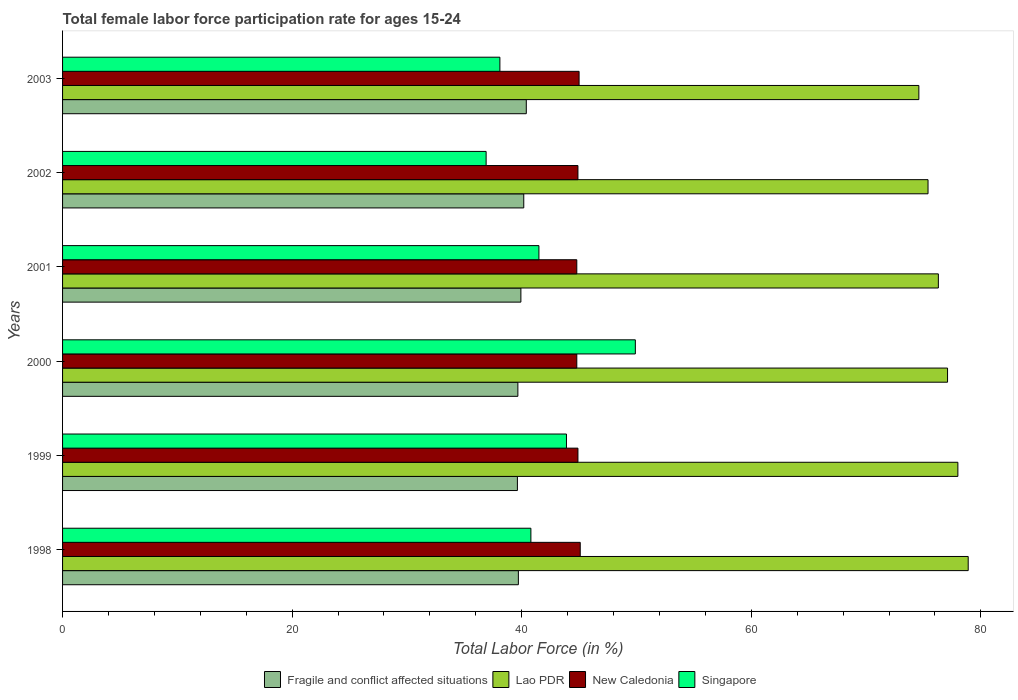How many different coloured bars are there?
Your answer should be very brief. 4. How many groups of bars are there?
Your response must be concise. 6. Are the number of bars per tick equal to the number of legend labels?
Provide a short and direct response. Yes. Are the number of bars on each tick of the Y-axis equal?
Provide a short and direct response. Yes. How many bars are there on the 2nd tick from the top?
Keep it short and to the point. 4. How many bars are there on the 6th tick from the bottom?
Offer a very short reply. 4. What is the female labor force participation rate in Singapore in 1999?
Give a very brief answer. 43.9. Across all years, what is the maximum female labor force participation rate in New Caledonia?
Your response must be concise. 45.1. Across all years, what is the minimum female labor force participation rate in Singapore?
Provide a succinct answer. 36.9. In which year was the female labor force participation rate in New Caledonia maximum?
Make the answer very short. 1998. What is the total female labor force participation rate in Singapore in the graph?
Ensure brevity in your answer.  251.1. What is the difference between the female labor force participation rate in Fragile and conflict affected situations in 1998 and that in 2000?
Make the answer very short. 0.04. What is the difference between the female labor force participation rate in Fragile and conflict affected situations in 2000 and the female labor force participation rate in Lao PDR in 2001?
Provide a short and direct response. -36.63. What is the average female labor force participation rate in Lao PDR per year?
Give a very brief answer. 76.72. In the year 2000, what is the difference between the female labor force participation rate in Singapore and female labor force participation rate in Lao PDR?
Your answer should be compact. -27.2. In how many years, is the female labor force participation rate in Fragile and conflict affected situations greater than 8 %?
Offer a terse response. 6. What is the ratio of the female labor force participation rate in Fragile and conflict affected situations in 1998 to that in 2002?
Keep it short and to the point. 0.99. Is the difference between the female labor force participation rate in Singapore in 1998 and 2001 greater than the difference between the female labor force participation rate in Lao PDR in 1998 and 2001?
Provide a succinct answer. No. What is the difference between the highest and the second highest female labor force participation rate in Fragile and conflict affected situations?
Keep it short and to the point. 0.22. What is the difference between the highest and the lowest female labor force participation rate in New Caledonia?
Provide a short and direct response. 0.3. Is the sum of the female labor force participation rate in Singapore in 2000 and 2001 greater than the maximum female labor force participation rate in Lao PDR across all years?
Your answer should be compact. Yes. What does the 1st bar from the top in 2000 represents?
Provide a short and direct response. Singapore. What does the 2nd bar from the bottom in 1999 represents?
Provide a succinct answer. Lao PDR. How many bars are there?
Give a very brief answer. 24. Are the values on the major ticks of X-axis written in scientific E-notation?
Offer a terse response. No. Does the graph contain grids?
Your answer should be very brief. No. How are the legend labels stacked?
Offer a terse response. Horizontal. What is the title of the graph?
Make the answer very short. Total female labor force participation rate for ages 15-24. What is the label or title of the X-axis?
Provide a short and direct response. Total Labor Force (in %). What is the label or title of the Y-axis?
Offer a very short reply. Years. What is the Total Labor Force (in %) of Fragile and conflict affected situations in 1998?
Your answer should be very brief. 39.71. What is the Total Labor Force (in %) in Lao PDR in 1998?
Offer a terse response. 78.9. What is the Total Labor Force (in %) in New Caledonia in 1998?
Your response must be concise. 45.1. What is the Total Labor Force (in %) of Singapore in 1998?
Offer a very short reply. 40.8. What is the Total Labor Force (in %) of Fragile and conflict affected situations in 1999?
Offer a terse response. 39.63. What is the Total Labor Force (in %) in New Caledonia in 1999?
Your answer should be very brief. 44.9. What is the Total Labor Force (in %) in Singapore in 1999?
Provide a succinct answer. 43.9. What is the Total Labor Force (in %) of Fragile and conflict affected situations in 2000?
Keep it short and to the point. 39.67. What is the Total Labor Force (in %) in Lao PDR in 2000?
Provide a succinct answer. 77.1. What is the Total Labor Force (in %) in New Caledonia in 2000?
Your response must be concise. 44.8. What is the Total Labor Force (in %) of Singapore in 2000?
Give a very brief answer. 49.9. What is the Total Labor Force (in %) of Fragile and conflict affected situations in 2001?
Provide a short and direct response. 39.93. What is the Total Labor Force (in %) in Lao PDR in 2001?
Your answer should be very brief. 76.3. What is the Total Labor Force (in %) in New Caledonia in 2001?
Ensure brevity in your answer.  44.8. What is the Total Labor Force (in %) in Singapore in 2001?
Your response must be concise. 41.5. What is the Total Labor Force (in %) in Fragile and conflict affected situations in 2002?
Your answer should be very brief. 40.18. What is the Total Labor Force (in %) in Lao PDR in 2002?
Offer a very short reply. 75.4. What is the Total Labor Force (in %) of New Caledonia in 2002?
Ensure brevity in your answer.  44.9. What is the Total Labor Force (in %) in Singapore in 2002?
Offer a very short reply. 36.9. What is the Total Labor Force (in %) of Fragile and conflict affected situations in 2003?
Make the answer very short. 40.4. What is the Total Labor Force (in %) of Lao PDR in 2003?
Provide a succinct answer. 74.6. What is the Total Labor Force (in %) in Singapore in 2003?
Your answer should be compact. 38.1. Across all years, what is the maximum Total Labor Force (in %) in Fragile and conflict affected situations?
Offer a terse response. 40.4. Across all years, what is the maximum Total Labor Force (in %) in Lao PDR?
Make the answer very short. 78.9. Across all years, what is the maximum Total Labor Force (in %) in New Caledonia?
Provide a short and direct response. 45.1. Across all years, what is the maximum Total Labor Force (in %) in Singapore?
Your response must be concise. 49.9. Across all years, what is the minimum Total Labor Force (in %) of Fragile and conflict affected situations?
Provide a short and direct response. 39.63. Across all years, what is the minimum Total Labor Force (in %) in Lao PDR?
Keep it short and to the point. 74.6. Across all years, what is the minimum Total Labor Force (in %) of New Caledonia?
Give a very brief answer. 44.8. Across all years, what is the minimum Total Labor Force (in %) in Singapore?
Make the answer very short. 36.9. What is the total Total Labor Force (in %) in Fragile and conflict affected situations in the graph?
Your response must be concise. 239.51. What is the total Total Labor Force (in %) of Lao PDR in the graph?
Provide a succinct answer. 460.3. What is the total Total Labor Force (in %) of New Caledonia in the graph?
Ensure brevity in your answer.  269.5. What is the total Total Labor Force (in %) of Singapore in the graph?
Your answer should be very brief. 251.1. What is the difference between the Total Labor Force (in %) of Fragile and conflict affected situations in 1998 and that in 1999?
Make the answer very short. 0.08. What is the difference between the Total Labor Force (in %) in Lao PDR in 1998 and that in 1999?
Your answer should be very brief. 0.9. What is the difference between the Total Labor Force (in %) in Singapore in 1998 and that in 1999?
Provide a succinct answer. -3.1. What is the difference between the Total Labor Force (in %) in Fragile and conflict affected situations in 1998 and that in 2000?
Ensure brevity in your answer.  0.04. What is the difference between the Total Labor Force (in %) of Lao PDR in 1998 and that in 2000?
Offer a very short reply. 1.8. What is the difference between the Total Labor Force (in %) of Singapore in 1998 and that in 2000?
Provide a succinct answer. -9.1. What is the difference between the Total Labor Force (in %) in Fragile and conflict affected situations in 1998 and that in 2001?
Make the answer very short. -0.22. What is the difference between the Total Labor Force (in %) of New Caledonia in 1998 and that in 2001?
Your response must be concise. 0.3. What is the difference between the Total Labor Force (in %) of Singapore in 1998 and that in 2001?
Offer a very short reply. -0.7. What is the difference between the Total Labor Force (in %) in Fragile and conflict affected situations in 1998 and that in 2002?
Your response must be concise. -0.47. What is the difference between the Total Labor Force (in %) of Lao PDR in 1998 and that in 2002?
Your answer should be very brief. 3.5. What is the difference between the Total Labor Force (in %) in New Caledonia in 1998 and that in 2002?
Provide a succinct answer. 0.2. What is the difference between the Total Labor Force (in %) of Fragile and conflict affected situations in 1998 and that in 2003?
Give a very brief answer. -0.69. What is the difference between the Total Labor Force (in %) of New Caledonia in 1998 and that in 2003?
Offer a terse response. 0.1. What is the difference between the Total Labor Force (in %) of Fragile and conflict affected situations in 1999 and that in 2000?
Offer a terse response. -0.04. What is the difference between the Total Labor Force (in %) of Singapore in 1999 and that in 2000?
Ensure brevity in your answer.  -6. What is the difference between the Total Labor Force (in %) in Fragile and conflict affected situations in 1999 and that in 2001?
Provide a succinct answer. -0.3. What is the difference between the Total Labor Force (in %) in New Caledonia in 1999 and that in 2001?
Provide a succinct answer. 0.1. What is the difference between the Total Labor Force (in %) of Fragile and conflict affected situations in 1999 and that in 2002?
Give a very brief answer. -0.55. What is the difference between the Total Labor Force (in %) of Lao PDR in 1999 and that in 2002?
Your answer should be compact. 2.6. What is the difference between the Total Labor Force (in %) of New Caledonia in 1999 and that in 2002?
Ensure brevity in your answer.  0. What is the difference between the Total Labor Force (in %) in Fragile and conflict affected situations in 1999 and that in 2003?
Your response must be concise. -0.78. What is the difference between the Total Labor Force (in %) of Fragile and conflict affected situations in 2000 and that in 2001?
Provide a short and direct response. -0.26. What is the difference between the Total Labor Force (in %) of Fragile and conflict affected situations in 2000 and that in 2002?
Your response must be concise. -0.51. What is the difference between the Total Labor Force (in %) in Lao PDR in 2000 and that in 2002?
Your answer should be compact. 1.7. What is the difference between the Total Labor Force (in %) in Singapore in 2000 and that in 2002?
Your answer should be very brief. 13. What is the difference between the Total Labor Force (in %) of Fragile and conflict affected situations in 2000 and that in 2003?
Offer a terse response. -0.73. What is the difference between the Total Labor Force (in %) in Lao PDR in 2000 and that in 2003?
Offer a terse response. 2.5. What is the difference between the Total Labor Force (in %) in New Caledonia in 2000 and that in 2003?
Ensure brevity in your answer.  -0.2. What is the difference between the Total Labor Force (in %) in Fragile and conflict affected situations in 2001 and that in 2002?
Your answer should be compact. -0.25. What is the difference between the Total Labor Force (in %) of New Caledonia in 2001 and that in 2002?
Keep it short and to the point. -0.1. What is the difference between the Total Labor Force (in %) of Fragile and conflict affected situations in 2001 and that in 2003?
Offer a very short reply. -0.47. What is the difference between the Total Labor Force (in %) of Singapore in 2001 and that in 2003?
Provide a short and direct response. 3.4. What is the difference between the Total Labor Force (in %) in Fragile and conflict affected situations in 2002 and that in 2003?
Provide a succinct answer. -0.22. What is the difference between the Total Labor Force (in %) in Singapore in 2002 and that in 2003?
Your answer should be compact. -1.2. What is the difference between the Total Labor Force (in %) of Fragile and conflict affected situations in 1998 and the Total Labor Force (in %) of Lao PDR in 1999?
Your response must be concise. -38.29. What is the difference between the Total Labor Force (in %) of Fragile and conflict affected situations in 1998 and the Total Labor Force (in %) of New Caledonia in 1999?
Provide a succinct answer. -5.19. What is the difference between the Total Labor Force (in %) in Fragile and conflict affected situations in 1998 and the Total Labor Force (in %) in Singapore in 1999?
Offer a terse response. -4.19. What is the difference between the Total Labor Force (in %) in New Caledonia in 1998 and the Total Labor Force (in %) in Singapore in 1999?
Ensure brevity in your answer.  1.2. What is the difference between the Total Labor Force (in %) in Fragile and conflict affected situations in 1998 and the Total Labor Force (in %) in Lao PDR in 2000?
Provide a succinct answer. -37.39. What is the difference between the Total Labor Force (in %) of Fragile and conflict affected situations in 1998 and the Total Labor Force (in %) of New Caledonia in 2000?
Provide a short and direct response. -5.09. What is the difference between the Total Labor Force (in %) of Fragile and conflict affected situations in 1998 and the Total Labor Force (in %) of Singapore in 2000?
Provide a short and direct response. -10.19. What is the difference between the Total Labor Force (in %) in Lao PDR in 1998 and the Total Labor Force (in %) in New Caledonia in 2000?
Keep it short and to the point. 34.1. What is the difference between the Total Labor Force (in %) in Lao PDR in 1998 and the Total Labor Force (in %) in Singapore in 2000?
Your response must be concise. 29. What is the difference between the Total Labor Force (in %) of Fragile and conflict affected situations in 1998 and the Total Labor Force (in %) of Lao PDR in 2001?
Keep it short and to the point. -36.59. What is the difference between the Total Labor Force (in %) of Fragile and conflict affected situations in 1998 and the Total Labor Force (in %) of New Caledonia in 2001?
Provide a short and direct response. -5.09. What is the difference between the Total Labor Force (in %) of Fragile and conflict affected situations in 1998 and the Total Labor Force (in %) of Singapore in 2001?
Provide a short and direct response. -1.79. What is the difference between the Total Labor Force (in %) in Lao PDR in 1998 and the Total Labor Force (in %) in New Caledonia in 2001?
Your answer should be very brief. 34.1. What is the difference between the Total Labor Force (in %) of Lao PDR in 1998 and the Total Labor Force (in %) of Singapore in 2001?
Your response must be concise. 37.4. What is the difference between the Total Labor Force (in %) in Fragile and conflict affected situations in 1998 and the Total Labor Force (in %) in Lao PDR in 2002?
Your answer should be compact. -35.69. What is the difference between the Total Labor Force (in %) of Fragile and conflict affected situations in 1998 and the Total Labor Force (in %) of New Caledonia in 2002?
Your answer should be very brief. -5.19. What is the difference between the Total Labor Force (in %) of Fragile and conflict affected situations in 1998 and the Total Labor Force (in %) of Singapore in 2002?
Your answer should be very brief. 2.81. What is the difference between the Total Labor Force (in %) of Fragile and conflict affected situations in 1998 and the Total Labor Force (in %) of Lao PDR in 2003?
Offer a terse response. -34.89. What is the difference between the Total Labor Force (in %) of Fragile and conflict affected situations in 1998 and the Total Labor Force (in %) of New Caledonia in 2003?
Your answer should be very brief. -5.29. What is the difference between the Total Labor Force (in %) in Fragile and conflict affected situations in 1998 and the Total Labor Force (in %) in Singapore in 2003?
Make the answer very short. 1.61. What is the difference between the Total Labor Force (in %) of Lao PDR in 1998 and the Total Labor Force (in %) of New Caledonia in 2003?
Make the answer very short. 33.9. What is the difference between the Total Labor Force (in %) of Lao PDR in 1998 and the Total Labor Force (in %) of Singapore in 2003?
Keep it short and to the point. 40.8. What is the difference between the Total Labor Force (in %) of New Caledonia in 1998 and the Total Labor Force (in %) of Singapore in 2003?
Provide a short and direct response. 7. What is the difference between the Total Labor Force (in %) in Fragile and conflict affected situations in 1999 and the Total Labor Force (in %) in Lao PDR in 2000?
Give a very brief answer. -37.47. What is the difference between the Total Labor Force (in %) of Fragile and conflict affected situations in 1999 and the Total Labor Force (in %) of New Caledonia in 2000?
Ensure brevity in your answer.  -5.17. What is the difference between the Total Labor Force (in %) in Fragile and conflict affected situations in 1999 and the Total Labor Force (in %) in Singapore in 2000?
Your answer should be very brief. -10.27. What is the difference between the Total Labor Force (in %) of Lao PDR in 1999 and the Total Labor Force (in %) of New Caledonia in 2000?
Your answer should be compact. 33.2. What is the difference between the Total Labor Force (in %) of Lao PDR in 1999 and the Total Labor Force (in %) of Singapore in 2000?
Your answer should be compact. 28.1. What is the difference between the Total Labor Force (in %) of Fragile and conflict affected situations in 1999 and the Total Labor Force (in %) of Lao PDR in 2001?
Provide a short and direct response. -36.67. What is the difference between the Total Labor Force (in %) of Fragile and conflict affected situations in 1999 and the Total Labor Force (in %) of New Caledonia in 2001?
Offer a very short reply. -5.17. What is the difference between the Total Labor Force (in %) in Fragile and conflict affected situations in 1999 and the Total Labor Force (in %) in Singapore in 2001?
Offer a very short reply. -1.87. What is the difference between the Total Labor Force (in %) in Lao PDR in 1999 and the Total Labor Force (in %) in New Caledonia in 2001?
Keep it short and to the point. 33.2. What is the difference between the Total Labor Force (in %) of Lao PDR in 1999 and the Total Labor Force (in %) of Singapore in 2001?
Offer a terse response. 36.5. What is the difference between the Total Labor Force (in %) in Fragile and conflict affected situations in 1999 and the Total Labor Force (in %) in Lao PDR in 2002?
Offer a very short reply. -35.77. What is the difference between the Total Labor Force (in %) in Fragile and conflict affected situations in 1999 and the Total Labor Force (in %) in New Caledonia in 2002?
Your answer should be very brief. -5.27. What is the difference between the Total Labor Force (in %) of Fragile and conflict affected situations in 1999 and the Total Labor Force (in %) of Singapore in 2002?
Give a very brief answer. 2.73. What is the difference between the Total Labor Force (in %) in Lao PDR in 1999 and the Total Labor Force (in %) in New Caledonia in 2002?
Give a very brief answer. 33.1. What is the difference between the Total Labor Force (in %) of Lao PDR in 1999 and the Total Labor Force (in %) of Singapore in 2002?
Keep it short and to the point. 41.1. What is the difference between the Total Labor Force (in %) of Fragile and conflict affected situations in 1999 and the Total Labor Force (in %) of Lao PDR in 2003?
Your answer should be compact. -34.97. What is the difference between the Total Labor Force (in %) of Fragile and conflict affected situations in 1999 and the Total Labor Force (in %) of New Caledonia in 2003?
Give a very brief answer. -5.37. What is the difference between the Total Labor Force (in %) in Fragile and conflict affected situations in 1999 and the Total Labor Force (in %) in Singapore in 2003?
Keep it short and to the point. 1.53. What is the difference between the Total Labor Force (in %) in Lao PDR in 1999 and the Total Labor Force (in %) in Singapore in 2003?
Keep it short and to the point. 39.9. What is the difference between the Total Labor Force (in %) in New Caledonia in 1999 and the Total Labor Force (in %) in Singapore in 2003?
Make the answer very short. 6.8. What is the difference between the Total Labor Force (in %) in Fragile and conflict affected situations in 2000 and the Total Labor Force (in %) in Lao PDR in 2001?
Give a very brief answer. -36.63. What is the difference between the Total Labor Force (in %) of Fragile and conflict affected situations in 2000 and the Total Labor Force (in %) of New Caledonia in 2001?
Provide a short and direct response. -5.13. What is the difference between the Total Labor Force (in %) in Fragile and conflict affected situations in 2000 and the Total Labor Force (in %) in Singapore in 2001?
Offer a very short reply. -1.83. What is the difference between the Total Labor Force (in %) of Lao PDR in 2000 and the Total Labor Force (in %) of New Caledonia in 2001?
Provide a short and direct response. 32.3. What is the difference between the Total Labor Force (in %) of Lao PDR in 2000 and the Total Labor Force (in %) of Singapore in 2001?
Keep it short and to the point. 35.6. What is the difference between the Total Labor Force (in %) of New Caledonia in 2000 and the Total Labor Force (in %) of Singapore in 2001?
Your answer should be compact. 3.3. What is the difference between the Total Labor Force (in %) of Fragile and conflict affected situations in 2000 and the Total Labor Force (in %) of Lao PDR in 2002?
Provide a short and direct response. -35.73. What is the difference between the Total Labor Force (in %) in Fragile and conflict affected situations in 2000 and the Total Labor Force (in %) in New Caledonia in 2002?
Keep it short and to the point. -5.23. What is the difference between the Total Labor Force (in %) of Fragile and conflict affected situations in 2000 and the Total Labor Force (in %) of Singapore in 2002?
Give a very brief answer. 2.77. What is the difference between the Total Labor Force (in %) of Lao PDR in 2000 and the Total Labor Force (in %) of New Caledonia in 2002?
Provide a succinct answer. 32.2. What is the difference between the Total Labor Force (in %) of Lao PDR in 2000 and the Total Labor Force (in %) of Singapore in 2002?
Your answer should be very brief. 40.2. What is the difference between the Total Labor Force (in %) in New Caledonia in 2000 and the Total Labor Force (in %) in Singapore in 2002?
Your answer should be very brief. 7.9. What is the difference between the Total Labor Force (in %) of Fragile and conflict affected situations in 2000 and the Total Labor Force (in %) of Lao PDR in 2003?
Your response must be concise. -34.93. What is the difference between the Total Labor Force (in %) of Fragile and conflict affected situations in 2000 and the Total Labor Force (in %) of New Caledonia in 2003?
Your answer should be compact. -5.33. What is the difference between the Total Labor Force (in %) in Fragile and conflict affected situations in 2000 and the Total Labor Force (in %) in Singapore in 2003?
Offer a very short reply. 1.57. What is the difference between the Total Labor Force (in %) of Lao PDR in 2000 and the Total Labor Force (in %) of New Caledonia in 2003?
Provide a succinct answer. 32.1. What is the difference between the Total Labor Force (in %) of New Caledonia in 2000 and the Total Labor Force (in %) of Singapore in 2003?
Make the answer very short. 6.7. What is the difference between the Total Labor Force (in %) of Fragile and conflict affected situations in 2001 and the Total Labor Force (in %) of Lao PDR in 2002?
Keep it short and to the point. -35.47. What is the difference between the Total Labor Force (in %) of Fragile and conflict affected situations in 2001 and the Total Labor Force (in %) of New Caledonia in 2002?
Your response must be concise. -4.97. What is the difference between the Total Labor Force (in %) in Fragile and conflict affected situations in 2001 and the Total Labor Force (in %) in Singapore in 2002?
Ensure brevity in your answer.  3.03. What is the difference between the Total Labor Force (in %) of Lao PDR in 2001 and the Total Labor Force (in %) of New Caledonia in 2002?
Your answer should be very brief. 31.4. What is the difference between the Total Labor Force (in %) in Lao PDR in 2001 and the Total Labor Force (in %) in Singapore in 2002?
Ensure brevity in your answer.  39.4. What is the difference between the Total Labor Force (in %) of Fragile and conflict affected situations in 2001 and the Total Labor Force (in %) of Lao PDR in 2003?
Make the answer very short. -34.67. What is the difference between the Total Labor Force (in %) of Fragile and conflict affected situations in 2001 and the Total Labor Force (in %) of New Caledonia in 2003?
Offer a terse response. -5.07. What is the difference between the Total Labor Force (in %) of Fragile and conflict affected situations in 2001 and the Total Labor Force (in %) of Singapore in 2003?
Make the answer very short. 1.83. What is the difference between the Total Labor Force (in %) of Lao PDR in 2001 and the Total Labor Force (in %) of New Caledonia in 2003?
Provide a succinct answer. 31.3. What is the difference between the Total Labor Force (in %) of Lao PDR in 2001 and the Total Labor Force (in %) of Singapore in 2003?
Your answer should be very brief. 38.2. What is the difference between the Total Labor Force (in %) in New Caledonia in 2001 and the Total Labor Force (in %) in Singapore in 2003?
Keep it short and to the point. 6.7. What is the difference between the Total Labor Force (in %) in Fragile and conflict affected situations in 2002 and the Total Labor Force (in %) in Lao PDR in 2003?
Provide a short and direct response. -34.42. What is the difference between the Total Labor Force (in %) of Fragile and conflict affected situations in 2002 and the Total Labor Force (in %) of New Caledonia in 2003?
Offer a very short reply. -4.82. What is the difference between the Total Labor Force (in %) in Fragile and conflict affected situations in 2002 and the Total Labor Force (in %) in Singapore in 2003?
Give a very brief answer. 2.08. What is the difference between the Total Labor Force (in %) in Lao PDR in 2002 and the Total Labor Force (in %) in New Caledonia in 2003?
Your response must be concise. 30.4. What is the difference between the Total Labor Force (in %) of Lao PDR in 2002 and the Total Labor Force (in %) of Singapore in 2003?
Make the answer very short. 37.3. What is the average Total Labor Force (in %) in Fragile and conflict affected situations per year?
Make the answer very short. 39.92. What is the average Total Labor Force (in %) of Lao PDR per year?
Your answer should be very brief. 76.72. What is the average Total Labor Force (in %) in New Caledonia per year?
Provide a succinct answer. 44.92. What is the average Total Labor Force (in %) in Singapore per year?
Ensure brevity in your answer.  41.85. In the year 1998, what is the difference between the Total Labor Force (in %) of Fragile and conflict affected situations and Total Labor Force (in %) of Lao PDR?
Your answer should be compact. -39.19. In the year 1998, what is the difference between the Total Labor Force (in %) of Fragile and conflict affected situations and Total Labor Force (in %) of New Caledonia?
Give a very brief answer. -5.39. In the year 1998, what is the difference between the Total Labor Force (in %) in Fragile and conflict affected situations and Total Labor Force (in %) in Singapore?
Make the answer very short. -1.09. In the year 1998, what is the difference between the Total Labor Force (in %) of Lao PDR and Total Labor Force (in %) of New Caledonia?
Provide a short and direct response. 33.8. In the year 1998, what is the difference between the Total Labor Force (in %) in Lao PDR and Total Labor Force (in %) in Singapore?
Provide a short and direct response. 38.1. In the year 1998, what is the difference between the Total Labor Force (in %) in New Caledonia and Total Labor Force (in %) in Singapore?
Your answer should be compact. 4.3. In the year 1999, what is the difference between the Total Labor Force (in %) of Fragile and conflict affected situations and Total Labor Force (in %) of Lao PDR?
Give a very brief answer. -38.37. In the year 1999, what is the difference between the Total Labor Force (in %) of Fragile and conflict affected situations and Total Labor Force (in %) of New Caledonia?
Your response must be concise. -5.27. In the year 1999, what is the difference between the Total Labor Force (in %) of Fragile and conflict affected situations and Total Labor Force (in %) of Singapore?
Offer a terse response. -4.27. In the year 1999, what is the difference between the Total Labor Force (in %) of Lao PDR and Total Labor Force (in %) of New Caledonia?
Your answer should be compact. 33.1. In the year 1999, what is the difference between the Total Labor Force (in %) of Lao PDR and Total Labor Force (in %) of Singapore?
Offer a very short reply. 34.1. In the year 2000, what is the difference between the Total Labor Force (in %) of Fragile and conflict affected situations and Total Labor Force (in %) of Lao PDR?
Make the answer very short. -37.43. In the year 2000, what is the difference between the Total Labor Force (in %) of Fragile and conflict affected situations and Total Labor Force (in %) of New Caledonia?
Offer a very short reply. -5.13. In the year 2000, what is the difference between the Total Labor Force (in %) of Fragile and conflict affected situations and Total Labor Force (in %) of Singapore?
Offer a terse response. -10.23. In the year 2000, what is the difference between the Total Labor Force (in %) in Lao PDR and Total Labor Force (in %) in New Caledonia?
Give a very brief answer. 32.3. In the year 2000, what is the difference between the Total Labor Force (in %) in Lao PDR and Total Labor Force (in %) in Singapore?
Keep it short and to the point. 27.2. In the year 2001, what is the difference between the Total Labor Force (in %) of Fragile and conflict affected situations and Total Labor Force (in %) of Lao PDR?
Keep it short and to the point. -36.37. In the year 2001, what is the difference between the Total Labor Force (in %) in Fragile and conflict affected situations and Total Labor Force (in %) in New Caledonia?
Your answer should be very brief. -4.87. In the year 2001, what is the difference between the Total Labor Force (in %) of Fragile and conflict affected situations and Total Labor Force (in %) of Singapore?
Offer a terse response. -1.57. In the year 2001, what is the difference between the Total Labor Force (in %) of Lao PDR and Total Labor Force (in %) of New Caledonia?
Your answer should be very brief. 31.5. In the year 2001, what is the difference between the Total Labor Force (in %) in Lao PDR and Total Labor Force (in %) in Singapore?
Your response must be concise. 34.8. In the year 2001, what is the difference between the Total Labor Force (in %) of New Caledonia and Total Labor Force (in %) of Singapore?
Offer a terse response. 3.3. In the year 2002, what is the difference between the Total Labor Force (in %) of Fragile and conflict affected situations and Total Labor Force (in %) of Lao PDR?
Provide a short and direct response. -35.22. In the year 2002, what is the difference between the Total Labor Force (in %) in Fragile and conflict affected situations and Total Labor Force (in %) in New Caledonia?
Offer a very short reply. -4.72. In the year 2002, what is the difference between the Total Labor Force (in %) of Fragile and conflict affected situations and Total Labor Force (in %) of Singapore?
Make the answer very short. 3.28. In the year 2002, what is the difference between the Total Labor Force (in %) in Lao PDR and Total Labor Force (in %) in New Caledonia?
Provide a succinct answer. 30.5. In the year 2002, what is the difference between the Total Labor Force (in %) in Lao PDR and Total Labor Force (in %) in Singapore?
Your answer should be compact. 38.5. In the year 2003, what is the difference between the Total Labor Force (in %) in Fragile and conflict affected situations and Total Labor Force (in %) in Lao PDR?
Ensure brevity in your answer.  -34.2. In the year 2003, what is the difference between the Total Labor Force (in %) in Fragile and conflict affected situations and Total Labor Force (in %) in New Caledonia?
Provide a short and direct response. -4.6. In the year 2003, what is the difference between the Total Labor Force (in %) in Fragile and conflict affected situations and Total Labor Force (in %) in Singapore?
Your answer should be very brief. 2.3. In the year 2003, what is the difference between the Total Labor Force (in %) of Lao PDR and Total Labor Force (in %) of New Caledonia?
Provide a short and direct response. 29.6. In the year 2003, what is the difference between the Total Labor Force (in %) of Lao PDR and Total Labor Force (in %) of Singapore?
Offer a terse response. 36.5. In the year 2003, what is the difference between the Total Labor Force (in %) of New Caledonia and Total Labor Force (in %) of Singapore?
Make the answer very short. 6.9. What is the ratio of the Total Labor Force (in %) in Lao PDR in 1998 to that in 1999?
Offer a very short reply. 1.01. What is the ratio of the Total Labor Force (in %) of Singapore in 1998 to that in 1999?
Provide a short and direct response. 0.93. What is the ratio of the Total Labor Force (in %) of Lao PDR in 1998 to that in 2000?
Your answer should be very brief. 1.02. What is the ratio of the Total Labor Force (in %) in New Caledonia in 1998 to that in 2000?
Offer a very short reply. 1.01. What is the ratio of the Total Labor Force (in %) of Singapore in 1998 to that in 2000?
Make the answer very short. 0.82. What is the ratio of the Total Labor Force (in %) of Fragile and conflict affected situations in 1998 to that in 2001?
Your response must be concise. 0.99. What is the ratio of the Total Labor Force (in %) in Lao PDR in 1998 to that in 2001?
Keep it short and to the point. 1.03. What is the ratio of the Total Labor Force (in %) in New Caledonia in 1998 to that in 2001?
Give a very brief answer. 1.01. What is the ratio of the Total Labor Force (in %) in Singapore in 1998 to that in 2001?
Your answer should be compact. 0.98. What is the ratio of the Total Labor Force (in %) in Fragile and conflict affected situations in 1998 to that in 2002?
Give a very brief answer. 0.99. What is the ratio of the Total Labor Force (in %) of Lao PDR in 1998 to that in 2002?
Ensure brevity in your answer.  1.05. What is the ratio of the Total Labor Force (in %) in New Caledonia in 1998 to that in 2002?
Keep it short and to the point. 1. What is the ratio of the Total Labor Force (in %) in Singapore in 1998 to that in 2002?
Your response must be concise. 1.11. What is the ratio of the Total Labor Force (in %) of Fragile and conflict affected situations in 1998 to that in 2003?
Your answer should be very brief. 0.98. What is the ratio of the Total Labor Force (in %) of Lao PDR in 1998 to that in 2003?
Your answer should be very brief. 1.06. What is the ratio of the Total Labor Force (in %) in New Caledonia in 1998 to that in 2003?
Ensure brevity in your answer.  1. What is the ratio of the Total Labor Force (in %) in Singapore in 1998 to that in 2003?
Offer a very short reply. 1.07. What is the ratio of the Total Labor Force (in %) of Lao PDR in 1999 to that in 2000?
Offer a very short reply. 1.01. What is the ratio of the Total Labor Force (in %) of Singapore in 1999 to that in 2000?
Offer a very short reply. 0.88. What is the ratio of the Total Labor Force (in %) of Fragile and conflict affected situations in 1999 to that in 2001?
Keep it short and to the point. 0.99. What is the ratio of the Total Labor Force (in %) in Lao PDR in 1999 to that in 2001?
Keep it short and to the point. 1.02. What is the ratio of the Total Labor Force (in %) of New Caledonia in 1999 to that in 2001?
Offer a very short reply. 1. What is the ratio of the Total Labor Force (in %) of Singapore in 1999 to that in 2001?
Your answer should be very brief. 1.06. What is the ratio of the Total Labor Force (in %) in Fragile and conflict affected situations in 1999 to that in 2002?
Provide a succinct answer. 0.99. What is the ratio of the Total Labor Force (in %) of Lao PDR in 1999 to that in 2002?
Make the answer very short. 1.03. What is the ratio of the Total Labor Force (in %) of Singapore in 1999 to that in 2002?
Your answer should be very brief. 1.19. What is the ratio of the Total Labor Force (in %) of Fragile and conflict affected situations in 1999 to that in 2003?
Your answer should be compact. 0.98. What is the ratio of the Total Labor Force (in %) in Lao PDR in 1999 to that in 2003?
Make the answer very short. 1.05. What is the ratio of the Total Labor Force (in %) of Singapore in 1999 to that in 2003?
Keep it short and to the point. 1.15. What is the ratio of the Total Labor Force (in %) of Lao PDR in 2000 to that in 2001?
Ensure brevity in your answer.  1.01. What is the ratio of the Total Labor Force (in %) in Singapore in 2000 to that in 2001?
Make the answer very short. 1.2. What is the ratio of the Total Labor Force (in %) in Fragile and conflict affected situations in 2000 to that in 2002?
Give a very brief answer. 0.99. What is the ratio of the Total Labor Force (in %) in Lao PDR in 2000 to that in 2002?
Keep it short and to the point. 1.02. What is the ratio of the Total Labor Force (in %) of New Caledonia in 2000 to that in 2002?
Keep it short and to the point. 1. What is the ratio of the Total Labor Force (in %) of Singapore in 2000 to that in 2002?
Your answer should be compact. 1.35. What is the ratio of the Total Labor Force (in %) in Fragile and conflict affected situations in 2000 to that in 2003?
Offer a terse response. 0.98. What is the ratio of the Total Labor Force (in %) in Lao PDR in 2000 to that in 2003?
Your answer should be very brief. 1.03. What is the ratio of the Total Labor Force (in %) in New Caledonia in 2000 to that in 2003?
Your answer should be compact. 1. What is the ratio of the Total Labor Force (in %) in Singapore in 2000 to that in 2003?
Provide a succinct answer. 1.31. What is the ratio of the Total Labor Force (in %) of Fragile and conflict affected situations in 2001 to that in 2002?
Keep it short and to the point. 0.99. What is the ratio of the Total Labor Force (in %) in Lao PDR in 2001 to that in 2002?
Provide a succinct answer. 1.01. What is the ratio of the Total Labor Force (in %) in New Caledonia in 2001 to that in 2002?
Your answer should be very brief. 1. What is the ratio of the Total Labor Force (in %) in Singapore in 2001 to that in 2002?
Keep it short and to the point. 1.12. What is the ratio of the Total Labor Force (in %) in Fragile and conflict affected situations in 2001 to that in 2003?
Your answer should be very brief. 0.99. What is the ratio of the Total Labor Force (in %) in Lao PDR in 2001 to that in 2003?
Provide a short and direct response. 1.02. What is the ratio of the Total Labor Force (in %) of New Caledonia in 2001 to that in 2003?
Make the answer very short. 1. What is the ratio of the Total Labor Force (in %) of Singapore in 2001 to that in 2003?
Offer a terse response. 1.09. What is the ratio of the Total Labor Force (in %) of Lao PDR in 2002 to that in 2003?
Your response must be concise. 1.01. What is the ratio of the Total Labor Force (in %) in New Caledonia in 2002 to that in 2003?
Give a very brief answer. 1. What is the ratio of the Total Labor Force (in %) in Singapore in 2002 to that in 2003?
Keep it short and to the point. 0.97. What is the difference between the highest and the second highest Total Labor Force (in %) of Fragile and conflict affected situations?
Ensure brevity in your answer.  0.22. What is the difference between the highest and the lowest Total Labor Force (in %) of Fragile and conflict affected situations?
Provide a succinct answer. 0.78. What is the difference between the highest and the lowest Total Labor Force (in %) in New Caledonia?
Your answer should be very brief. 0.3. What is the difference between the highest and the lowest Total Labor Force (in %) in Singapore?
Offer a terse response. 13. 